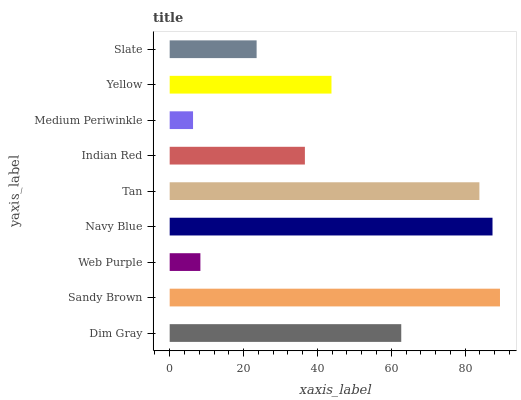Is Medium Periwinkle the minimum?
Answer yes or no. Yes. Is Sandy Brown the maximum?
Answer yes or no. Yes. Is Web Purple the minimum?
Answer yes or no. No. Is Web Purple the maximum?
Answer yes or no. No. Is Sandy Brown greater than Web Purple?
Answer yes or no. Yes. Is Web Purple less than Sandy Brown?
Answer yes or no. Yes. Is Web Purple greater than Sandy Brown?
Answer yes or no. No. Is Sandy Brown less than Web Purple?
Answer yes or no. No. Is Yellow the high median?
Answer yes or no. Yes. Is Yellow the low median?
Answer yes or no. Yes. Is Dim Gray the high median?
Answer yes or no. No. Is Medium Periwinkle the low median?
Answer yes or no. No. 